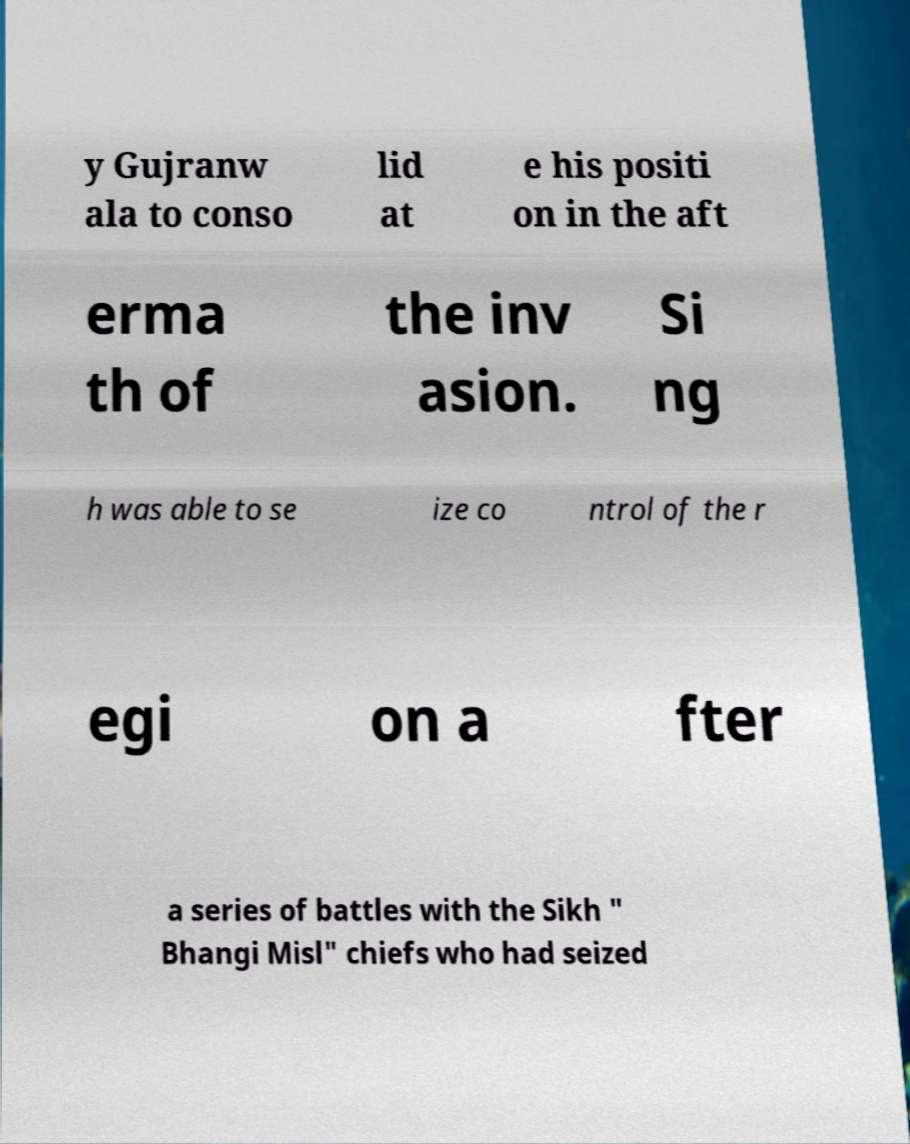I need the written content from this picture converted into text. Can you do that? y Gujranw ala to conso lid at e his positi on in the aft erma th of the inv asion. Si ng h was able to se ize co ntrol of the r egi on a fter a series of battles with the Sikh " Bhangi Misl" chiefs who had seized 